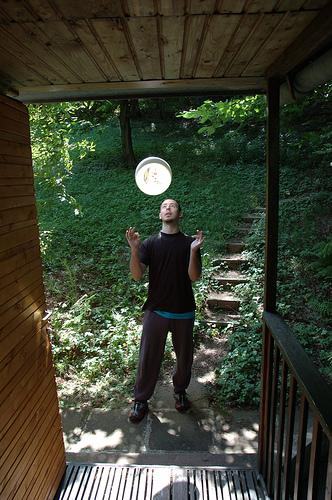Describe the outdoor setting in which the image takes place. The image shows a wooded area with lots of green foliage, a stepped pathway, a porch, and a concrete slab patio outside of a house with light pine wood siding. What does the shadow in the image belong to? The shadow in the image belongs to the ball that is flying in the air. What is the man in the image attempting to catch? The man is trying to catch a white ball, also described as a "white freebie" and "round pan," which is flying in the air. What kind of clothes is the man wearing in the image? The man is wearing a navy blue t-shirt, comfortable sweatpants or warm ups, and black gray and red tennis shoes. Count how many instances of the color black there are in the clothing and objects of the image. There are four instances: black gray and red tennis shoes, a black shirt, black and red shoes, and the railings made of wood. What type of plant is prominent around the pathway in the image? Green trailing ivy bushes are prominent around the pathway. Identify an object in the image that may be a source of potential danger. A round metal pan flying in the air could be a potential danger as the man tries to catch it. What kind of flooring is seen in the image? In the image, there is a cement slab patio and wooden slats on the floor of the porch. Describe the pathway featured in the image. The pathway is a stepped pathway with wooden slates in the dirt for natural stairs, winding up a hill and surrounded by ivy. List three distinct objects found in the image. A man catching a ball, a wooden porch, and a pathway with steps surrounded by ivy. What is flying in the air in the image? A white ball or a round metal pan Are the shoes of the man blue and white in color? The man is wearing black, gray, and red tennis shoes (X:124 Y:390 Width:70 Height:70), not blue and white. What is on the pathway near the man? Concrete slab patio and concrete stairs going to the garden Identify the material of the porch of the house. Wood In the image, what type of pants does the man wear?  Comfortable sweatpants or warm-ups Is the man wearing a light blue shirt or a navy blue t-shirt with a light blue shirt underneath? A navy blue t-shirt with a light blue shirt underneath Is the man trying to catch a football instead of the round metal pan? The man is trying to catch a round metal pan (X:135 Y:155 Width:36 Height:36) and not a football. Write a sentence about the scene portraying the man and the flying object. A man is standing under a white ball or a round metal pan, attempting to catch it as it comes down. How can we describe the daylight in the scene? Very little sun coming through the trees What is a prominent feature in the man's neck region? The man's Adam's apple Is the shirt that the man is wearing in the image light blue or black? Black, though layered with a light blue shirt underneath Does the wooden structure in front of the man have purple flowers on it? There is no mention of purple flowers on the wooden structure (X:4 Y:314 Width:261 Height:261), and the instructions describe green foliage (X:37 Y:109 Width:287 Height:287) and trailing ivy bushes (X:282 Y:105 Width:46 Height:46) instead. What type of bird is pictured on the round metal pan? A yellow bird Are the wooden slates in the dirt used for a playground? The wooden slates (X:164 Y:189 Width:161 Height:161) are actually used as natural stairs, not for a playground. Is the man wearing a pink shirt and yellow pants? The man is actually wearing a navy blue tee shirt with a light blue shirt underneath (X:121 Y:196 Width:86 Height:86) and comfortable sweatpants (X:126 Y:197 Width:82 Height:82) for kicking back. Is there a wooded area outside the house? Yes What action is the man performing? Trying to catch a white ball or a round metal pan in the air a) Wooden slats c) Cement blocks Describe the pathway in the scene. A stepped pathway winds up a hill, surrounded by ivy with wooden slates in the dirt as natural stairs. What color and type are the man's shoes? Black, gray, and red tennis shoes Describe the wooden structure that is in front of the man. Covered porch made of wood with wooden railings and a wooden fence What type of plants can be seen in the wooded area outside the house? Lots of green foliage, green trailing ivy bushes, and a tree Does the man in the image have a beard or is clean shaven?  Cannot determine Is the ball located near the bottom-right corner of the image? The ball is not near the bottom-right corner; its actual position is X:132, Y:153, while the bottom-right corner would have high X and Y values. What emotion does the man in the picture seem to be expressing while catching the object? Intense concentration 